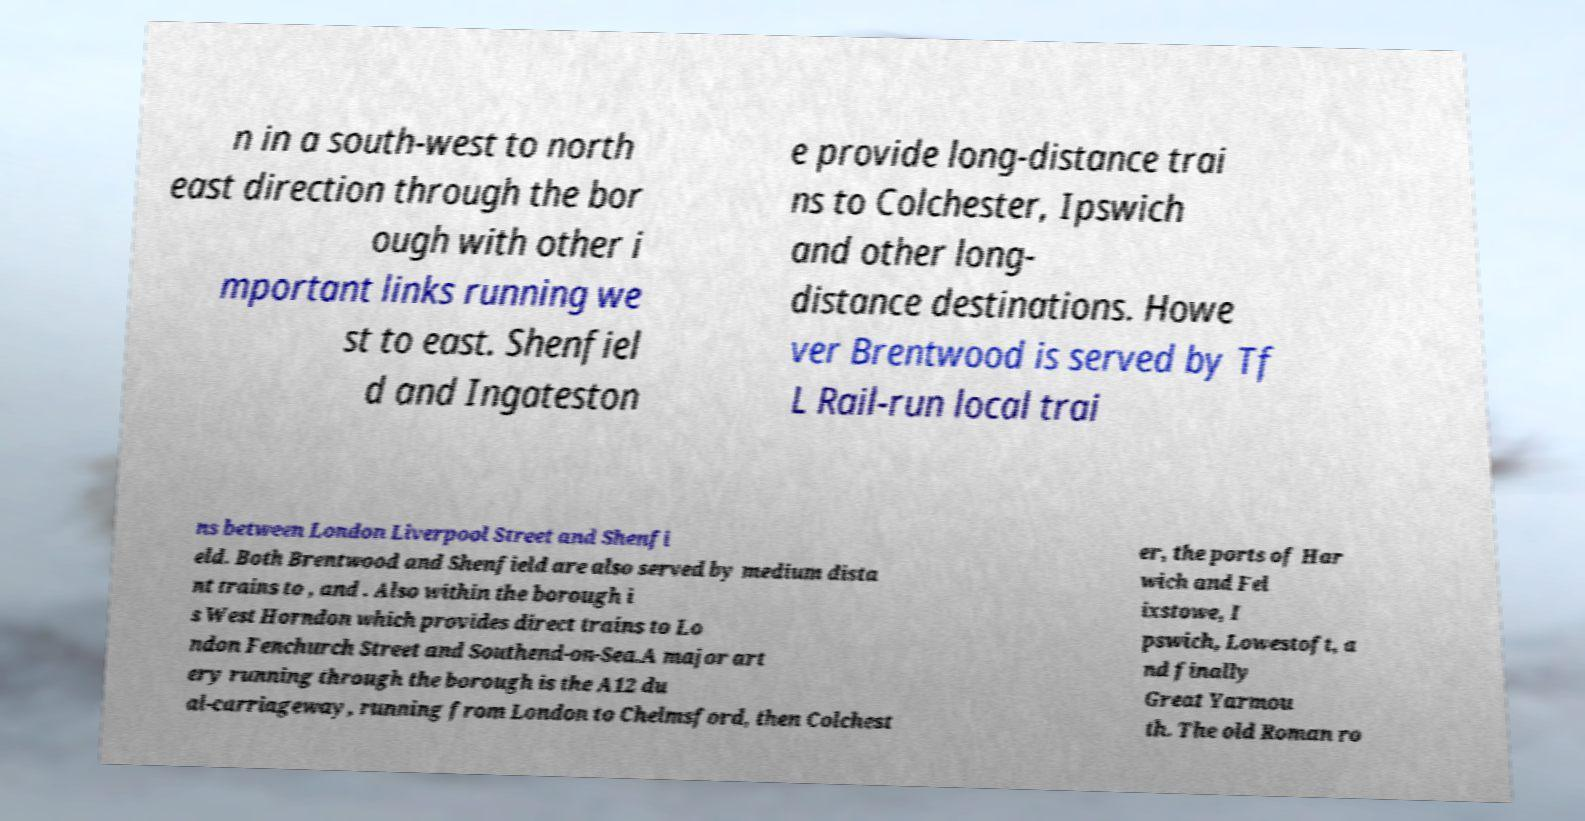There's text embedded in this image that I need extracted. Can you transcribe it verbatim? n in a south-west to north east direction through the bor ough with other i mportant links running we st to east. Shenfiel d and Ingateston e provide long-distance trai ns to Colchester, Ipswich and other long- distance destinations. Howe ver Brentwood is served by Tf L Rail-run local trai ns between London Liverpool Street and Shenfi eld. Both Brentwood and Shenfield are also served by medium dista nt trains to , and . Also within the borough i s West Horndon which provides direct trains to Lo ndon Fenchurch Street and Southend-on-Sea.A major art ery running through the borough is the A12 du al-carriageway, running from London to Chelmsford, then Colchest er, the ports of Har wich and Fel ixstowe, I pswich, Lowestoft, a nd finally Great Yarmou th. The old Roman ro 